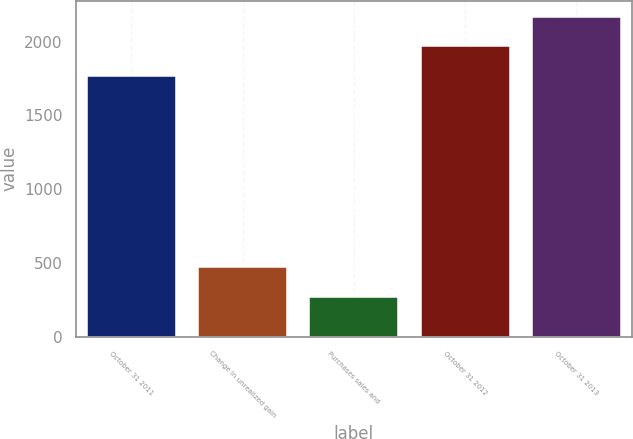<chart> <loc_0><loc_0><loc_500><loc_500><bar_chart><fcel>October 31 2011<fcel>Change in unrealized gain<fcel>Purchases sales and<fcel>October 31 2012<fcel>October 31 2013<nl><fcel>1765<fcel>471.6<fcel>272.8<fcel>1969<fcel>2167.8<nl></chart> 